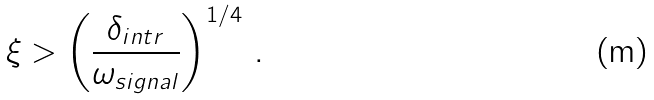Convert formula to latex. <formula><loc_0><loc_0><loc_500><loc_500>\xi > \left ( \frac { \delta _ { i n t r } } { \omega _ { s i g n a l } } \right ) ^ { 1 / 4 } \, .</formula> 